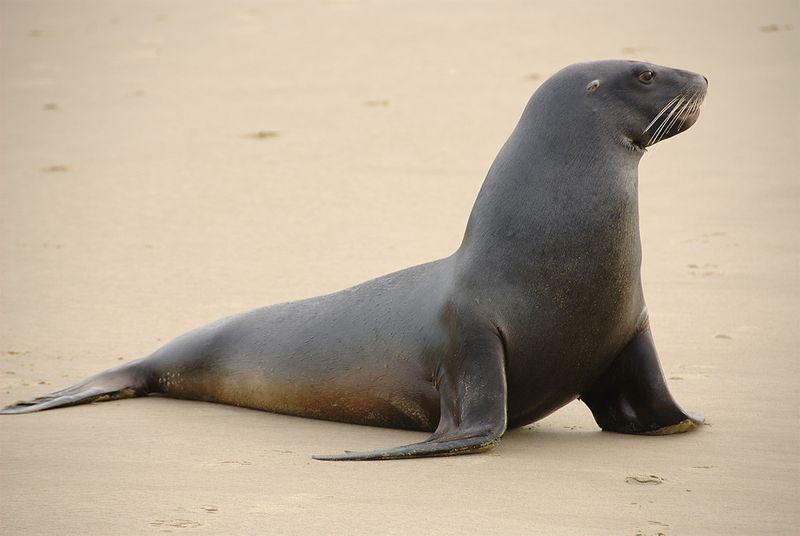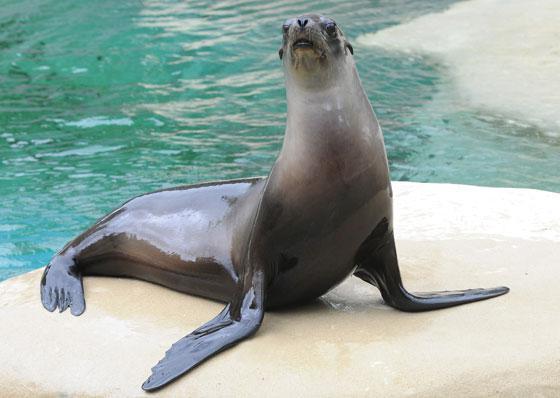The first image is the image on the left, the second image is the image on the right. Evaluate the accuracy of this statement regarding the images: "In one of the images there is a single seal next to the edge of a swimming pool.". Is it true? Answer yes or no. Yes. 